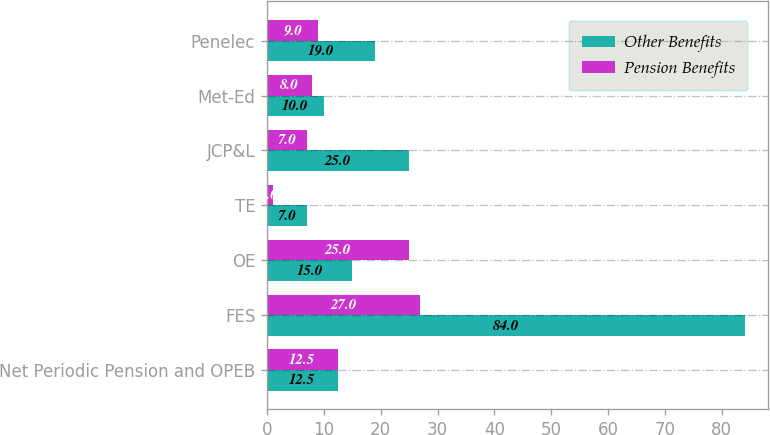<chart> <loc_0><loc_0><loc_500><loc_500><stacked_bar_chart><ecel><fcel>Net Periodic Pension and OPEB<fcel>FES<fcel>OE<fcel>TE<fcel>JCP&L<fcel>Met-Ed<fcel>Penelec<nl><fcel>Other Benefits<fcel>12.5<fcel>84<fcel>15<fcel>7<fcel>25<fcel>10<fcel>19<nl><fcel>Pension Benefits<fcel>12.5<fcel>27<fcel>25<fcel>1<fcel>7<fcel>8<fcel>9<nl></chart> 